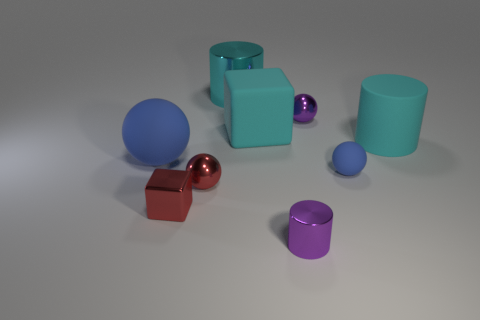There is a cyan shiny object; what shape is it?
Give a very brief answer. Cylinder. There is a blue matte object right of the large blue thing; is it the same shape as the large blue thing?
Provide a succinct answer. Yes. Are there more cubes that are to the left of the small red metallic ball than large metallic objects right of the big cyan matte cylinder?
Make the answer very short. Yes. How many other things are there of the same size as the purple ball?
Give a very brief answer. 4. Does the big metal object have the same shape as the cyan matte object right of the tiny blue thing?
Give a very brief answer. Yes. What number of shiny things are either small cubes or red things?
Make the answer very short. 2. Are there any tiny objects of the same color as the tiny metallic cylinder?
Provide a short and direct response. Yes. Are any green things visible?
Your answer should be very brief. No. Is the shape of the cyan shiny thing the same as the large blue object?
Offer a terse response. No. What number of tiny objects are either blue objects or red shiny things?
Offer a terse response. 3. 